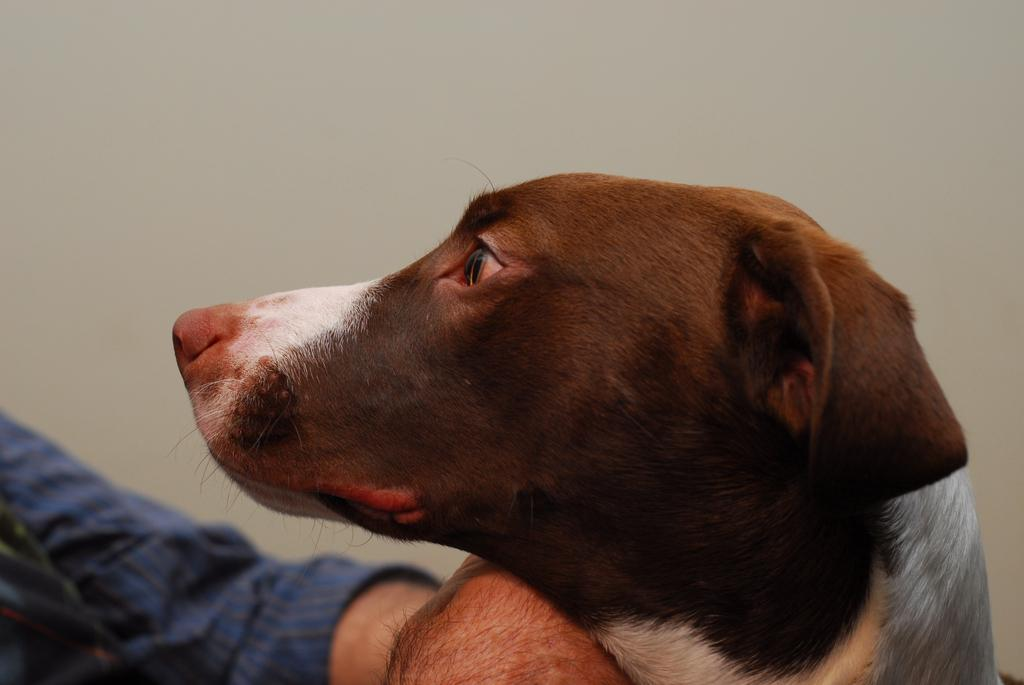Who is present in the image? There is a man in the image. What is the man wearing? The man is wearing a blue shirt. What is the man holding in the image? The man is holding a dog. Can you describe the dog's appearance? The dog has brown, black, and white colors. What can be seen in the background of the image? There is a wall visible in the background of the image. What type of lettuce is the man using to feed the ladybug in the image? There is no ladybug or lettuce present in the image. What kind of meat is the dog eating in the image? There is no meat present in the image; the man is holding a dog, but there is no indication that the dog is eating anything. 